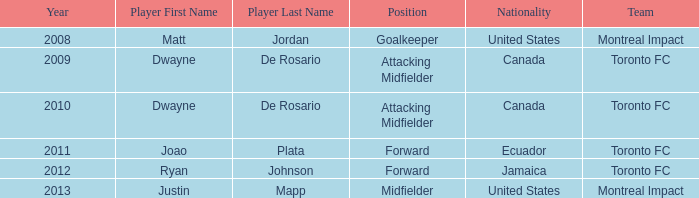After 2009, what's the nationality of a player named Dwayne de Rosario Category:articles with hcards? Canada. 